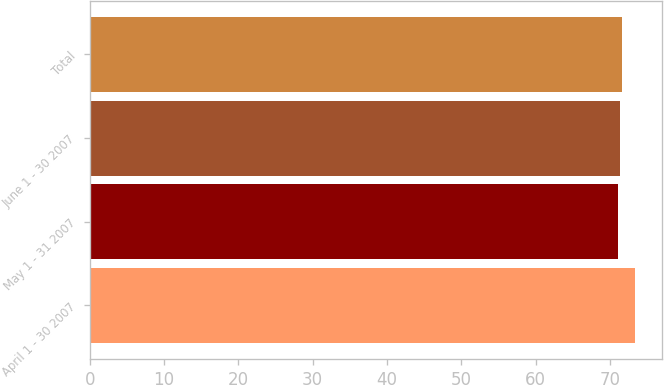Convert chart to OTSL. <chart><loc_0><loc_0><loc_500><loc_500><bar_chart><fcel>April 1 - 30 2007<fcel>May 1 - 31 2007<fcel>June 1 - 30 2007<fcel>Total<nl><fcel>73.33<fcel>71.09<fcel>71.31<fcel>71.56<nl></chart> 